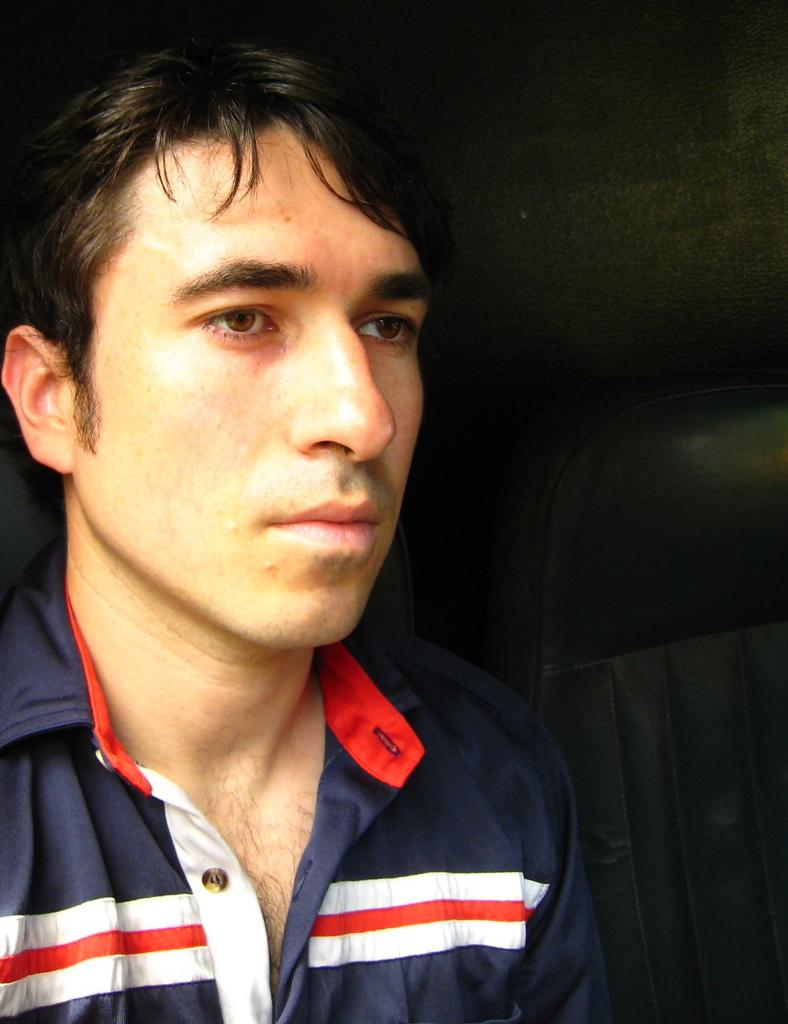Who is present in the image? There is a man in the image. What is located beside the man? There is a seat beside the man. What can be observed about the background of the image? The background of the image is dark. What type of stone is hanging from the hook in the image? There is no stone or hook present in the image. What is the man doing with the mailbox in the image? There is no mailbox present in the image. 